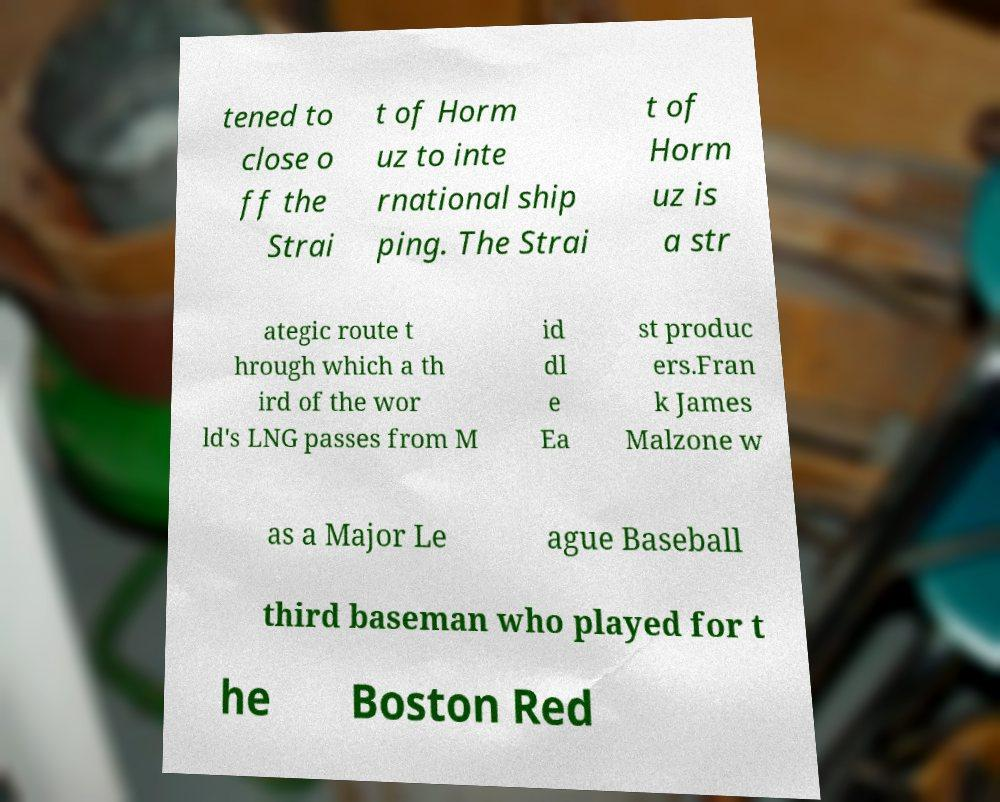There's text embedded in this image that I need extracted. Can you transcribe it verbatim? tened to close o ff the Strai t of Horm uz to inte rnational ship ping. The Strai t of Horm uz is a str ategic route t hrough which a th ird of the wor ld's LNG passes from M id dl e Ea st produc ers.Fran k James Malzone w as a Major Le ague Baseball third baseman who played for t he Boston Red 